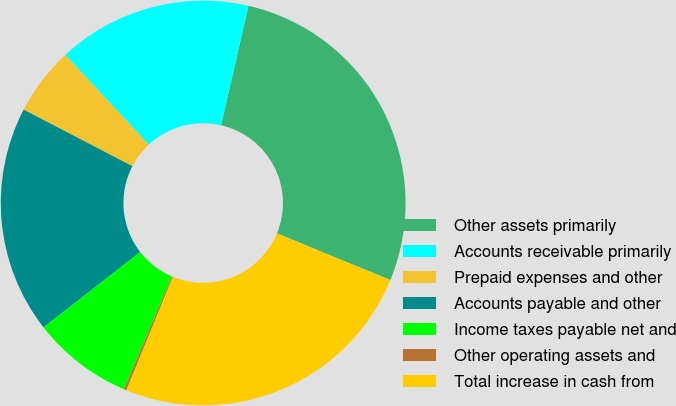Convert chart to OTSL. <chart><loc_0><loc_0><loc_500><loc_500><pie_chart><fcel>Other assets primarily<fcel>Accounts receivable primarily<fcel>Prepaid expenses and other<fcel>Accounts payable and other<fcel>Income taxes payable net and<fcel>Other operating assets and<fcel>Total increase in cash from<nl><fcel>27.62%<fcel>15.53%<fcel>5.43%<fcel>18.17%<fcel>8.07%<fcel>0.2%<fcel>24.98%<nl></chart> 